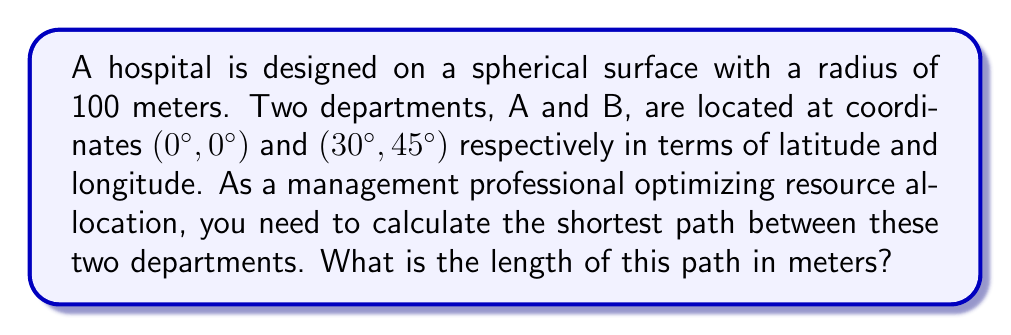Give your solution to this math problem. To solve this problem, we'll use the great circle distance formula, which gives the shortest path between two points on a sphere. Here's the step-by-step solution:

1) The great circle distance formula is:

   $$d = r \cdot \arccos(\sin\phi_1 \sin\phi_2 + \cos\phi_1 \cos\phi_2 \cos(\lambda_2 - \lambda_1))$$

   Where:
   $r$ is the radius of the sphere
   $\phi_1, \phi_2$ are the latitudes of the two points
   $\lambda_1, \lambda_2$ are the longitudes of the two points

2) Given:
   $r = 100$ meters
   Point A: $\phi_1 = 0°, \lambda_1 = 0°$
   Point B: $\phi_2 = 30°, \lambda_2 = 45°$

3) Convert degrees to radians:
   $0° = 0$ radians
   $30° = \frac{\pi}{6}$ radians
   $45° = \frac{\pi}{4}$ radians

4) Substitute into the formula:

   $$d = 100 \cdot \arccos(\sin(0) \sin(\frac{\pi}{6}) + \cos(0) \cos(\frac{\pi}{6}) \cos(\frac{\pi}{4} - 0))$$

5) Simplify:

   $$d = 100 \cdot \arccos(0 + \cos(\frac{\pi}{6}) \cos(\frac{\pi}{4}))$$

6) Calculate:

   $$d = 100 \cdot \arccos((\frac{\sqrt{3}}{2}) \cdot (\frac{\sqrt{2}}{2}))$$
   $$d = 100 \cdot \arccos(\frac{\sqrt{6}}{4})$$
   $$d \approx 100 \cdot 0.7418$$
   $$d \approx 74.18 \text{ meters}$$
Answer: 74.18 meters 